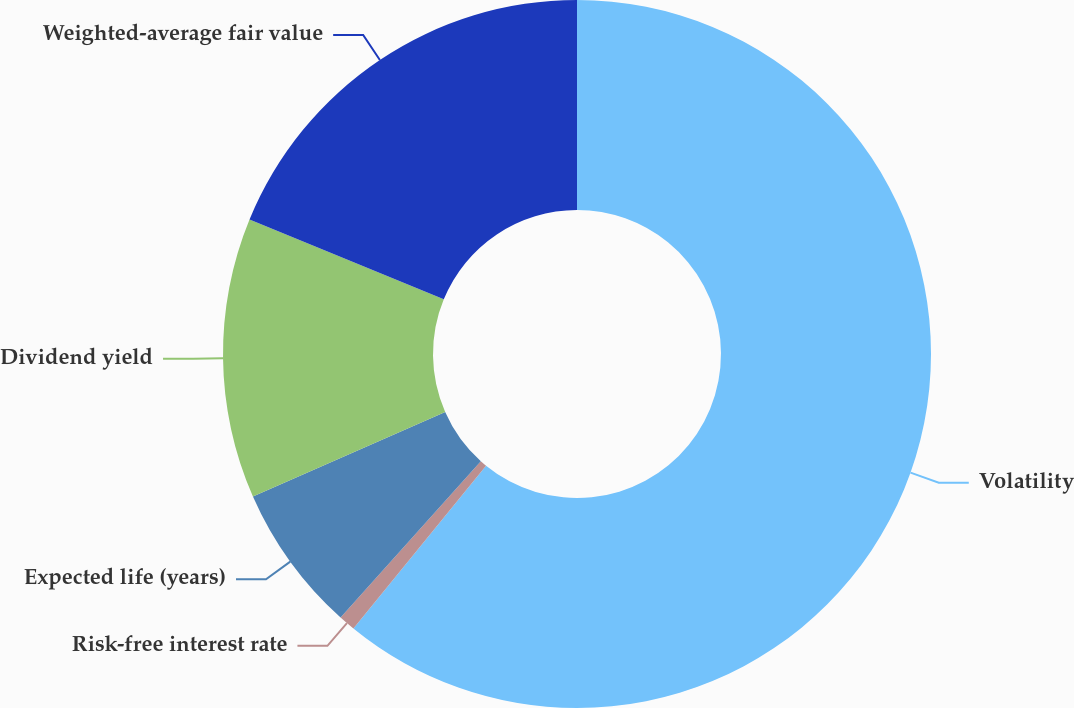<chart> <loc_0><loc_0><loc_500><loc_500><pie_chart><fcel>Volatility<fcel>Risk-free interest rate<fcel>Expected life (years)<fcel>Dividend yield<fcel>Weighted-average fair value<nl><fcel>60.88%<fcel>0.76%<fcel>6.77%<fcel>12.79%<fcel>18.8%<nl></chart> 